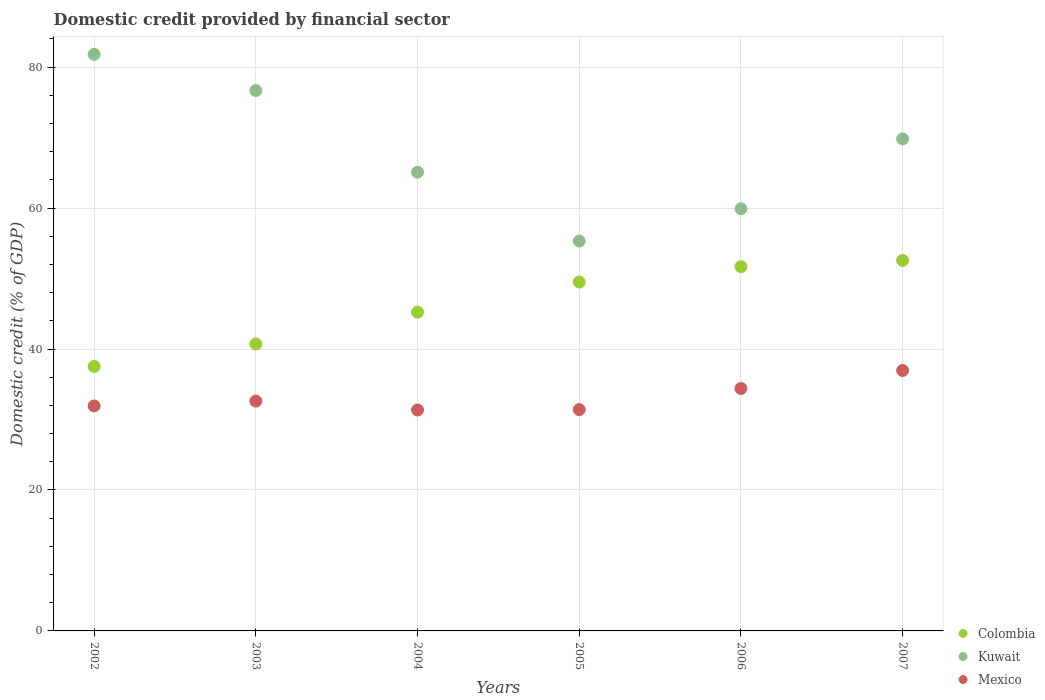Is the number of dotlines equal to the number of legend labels?
Keep it short and to the point. Yes. What is the domestic credit in Colombia in 2002?
Your response must be concise. 37.53. Across all years, what is the maximum domestic credit in Kuwait?
Ensure brevity in your answer.  81.81. Across all years, what is the minimum domestic credit in Colombia?
Provide a succinct answer. 37.53. In which year was the domestic credit in Colombia maximum?
Your answer should be compact. 2007. In which year was the domestic credit in Kuwait minimum?
Your answer should be compact. 2005. What is the total domestic credit in Mexico in the graph?
Provide a succinct answer. 198.64. What is the difference between the domestic credit in Mexico in 2003 and that in 2005?
Offer a terse response. 1.2. What is the difference between the domestic credit in Colombia in 2006 and the domestic credit in Mexico in 2002?
Your answer should be very brief. 19.76. What is the average domestic credit in Mexico per year?
Keep it short and to the point. 33.11. In the year 2004, what is the difference between the domestic credit in Mexico and domestic credit in Colombia?
Provide a short and direct response. -13.89. What is the ratio of the domestic credit in Mexico in 2002 to that in 2007?
Keep it short and to the point. 0.86. Is the domestic credit in Kuwait in 2003 less than that in 2004?
Your response must be concise. No. What is the difference between the highest and the second highest domestic credit in Mexico?
Provide a succinct answer. 2.55. What is the difference between the highest and the lowest domestic credit in Colombia?
Offer a terse response. 15.04. In how many years, is the domestic credit in Colombia greater than the average domestic credit in Colombia taken over all years?
Your answer should be compact. 3. Is the sum of the domestic credit in Kuwait in 2004 and 2005 greater than the maximum domestic credit in Mexico across all years?
Your response must be concise. Yes. Is the domestic credit in Mexico strictly greater than the domestic credit in Colombia over the years?
Give a very brief answer. No. How many dotlines are there?
Your answer should be compact. 3. What is the difference between two consecutive major ticks on the Y-axis?
Make the answer very short. 20. Where does the legend appear in the graph?
Your answer should be very brief. Bottom right. How are the legend labels stacked?
Provide a succinct answer. Vertical. What is the title of the graph?
Give a very brief answer. Domestic credit provided by financial sector. Does "Finland" appear as one of the legend labels in the graph?
Make the answer very short. No. What is the label or title of the X-axis?
Your response must be concise. Years. What is the label or title of the Y-axis?
Provide a succinct answer. Domestic credit (% of GDP). What is the Domestic credit (% of GDP) in Colombia in 2002?
Your answer should be compact. 37.53. What is the Domestic credit (% of GDP) in Kuwait in 2002?
Your response must be concise. 81.81. What is the Domestic credit (% of GDP) in Mexico in 2002?
Your response must be concise. 31.92. What is the Domestic credit (% of GDP) of Colombia in 2003?
Provide a succinct answer. 40.72. What is the Domestic credit (% of GDP) of Kuwait in 2003?
Your answer should be compact. 76.68. What is the Domestic credit (% of GDP) of Mexico in 2003?
Provide a short and direct response. 32.61. What is the Domestic credit (% of GDP) of Colombia in 2004?
Your response must be concise. 45.23. What is the Domestic credit (% of GDP) of Kuwait in 2004?
Your answer should be compact. 65.09. What is the Domestic credit (% of GDP) of Mexico in 2004?
Give a very brief answer. 31.35. What is the Domestic credit (% of GDP) in Colombia in 2005?
Your response must be concise. 49.5. What is the Domestic credit (% of GDP) in Kuwait in 2005?
Offer a very short reply. 55.32. What is the Domestic credit (% of GDP) of Mexico in 2005?
Offer a very short reply. 31.41. What is the Domestic credit (% of GDP) of Colombia in 2006?
Your answer should be very brief. 51.68. What is the Domestic credit (% of GDP) of Kuwait in 2006?
Ensure brevity in your answer.  59.91. What is the Domestic credit (% of GDP) in Mexico in 2006?
Offer a very short reply. 34.4. What is the Domestic credit (% of GDP) of Colombia in 2007?
Your response must be concise. 52.57. What is the Domestic credit (% of GDP) of Kuwait in 2007?
Provide a short and direct response. 69.82. What is the Domestic credit (% of GDP) of Mexico in 2007?
Offer a very short reply. 36.95. Across all years, what is the maximum Domestic credit (% of GDP) of Colombia?
Your answer should be compact. 52.57. Across all years, what is the maximum Domestic credit (% of GDP) in Kuwait?
Provide a succinct answer. 81.81. Across all years, what is the maximum Domestic credit (% of GDP) in Mexico?
Keep it short and to the point. 36.95. Across all years, what is the minimum Domestic credit (% of GDP) of Colombia?
Offer a terse response. 37.53. Across all years, what is the minimum Domestic credit (% of GDP) in Kuwait?
Keep it short and to the point. 55.32. Across all years, what is the minimum Domestic credit (% of GDP) in Mexico?
Ensure brevity in your answer.  31.35. What is the total Domestic credit (% of GDP) of Colombia in the graph?
Give a very brief answer. 277.24. What is the total Domestic credit (% of GDP) in Kuwait in the graph?
Ensure brevity in your answer.  408.62. What is the total Domestic credit (% of GDP) of Mexico in the graph?
Provide a short and direct response. 198.64. What is the difference between the Domestic credit (% of GDP) in Colombia in 2002 and that in 2003?
Your response must be concise. -3.19. What is the difference between the Domestic credit (% of GDP) of Kuwait in 2002 and that in 2003?
Offer a very short reply. 5.13. What is the difference between the Domestic credit (% of GDP) in Mexico in 2002 and that in 2003?
Your response must be concise. -0.69. What is the difference between the Domestic credit (% of GDP) of Colombia in 2002 and that in 2004?
Ensure brevity in your answer.  -7.71. What is the difference between the Domestic credit (% of GDP) of Kuwait in 2002 and that in 2004?
Provide a succinct answer. 16.72. What is the difference between the Domestic credit (% of GDP) in Mexico in 2002 and that in 2004?
Offer a terse response. 0.58. What is the difference between the Domestic credit (% of GDP) in Colombia in 2002 and that in 2005?
Offer a very short reply. -11.97. What is the difference between the Domestic credit (% of GDP) in Kuwait in 2002 and that in 2005?
Provide a short and direct response. 26.49. What is the difference between the Domestic credit (% of GDP) of Mexico in 2002 and that in 2005?
Offer a very short reply. 0.52. What is the difference between the Domestic credit (% of GDP) in Colombia in 2002 and that in 2006?
Ensure brevity in your answer.  -14.15. What is the difference between the Domestic credit (% of GDP) of Kuwait in 2002 and that in 2006?
Provide a succinct answer. 21.9. What is the difference between the Domestic credit (% of GDP) in Mexico in 2002 and that in 2006?
Your response must be concise. -2.48. What is the difference between the Domestic credit (% of GDP) of Colombia in 2002 and that in 2007?
Offer a very short reply. -15.04. What is the difference between the Domestic credit (% of GDP) of Kuwait in 2002 and that in 2007?
Keep it short and to the point. 11.99. What is the difference between the Domestic credit (% of GDP) in Mexico in 2002 and that in 2007?
Give a very brief answer. -5.03. What is the difference between the Domestic credit (% of GDP) in Colombia in 2003 and that in 2004?
Ensure brevity in your answer.  -4.52. What is the difference between the Domestic credit (% of GDP) in Kuwait in 2003 and that in 2004?
Provide a succinct answer. 11.59. What is the difference between the Domestic credit (% of GDP) in Mexico in 2003 and that in 2004?
Provide a succinct answer. 1.26. What is the difference between the Domestic credit (% of GDP) in Colombia in 2003 and that in 2005?
Your response must be concise. -8.79. What is the difference between the Domestic credit (% of GDP) of Kuwait in 2003 and that in 2005?
Offer a very short reply. 21.36. What is the difference between the Domestic credit (% of GDP) in Mexico in 2003 and that in 2005?
Make the answer very short. 1.2. What is the difference between the Domestic credit (% of GDP) in Colombia in 2003 and that in 2006?
Offer a very short reply. -10.97. What is the difference between the Domestic credit (% of GDP) of Kuwait in 2003 and that in 2006?
Provide a short and direct response. 16.77. What is the difference between the Domestic credit (% of GDP) in Mexico in 2003 and that in 2006?
Offer a terse response. -1.79. What is the difference between the Domestic credit (% of GDP) of Colombia in 2003 and that in 2007?
Your answer should be compact. -11.85. What is the difference between the Domestic credit (% of GDP) of Kuwait in 2003 and that in 2007?
Give a very brief answer. 6.86. What is the difference between the Domestic credit (% of GDP) of Mexico in 2003 and that in 2007?
Provide a succinct answer. -4.34. What is the difference between the Domestic credit (% of GDP) in Colombia in 2004 and that in 2005?
Your answer should be compact. -4.27. What is the difference between the Domestic credit (% of GDP) of Kuwait in 2004 and that in 2005?
Offer a very short reply. 9.77. What is the difference between the Domestic credit (% of GDP) of Mexico in 2004 and that in 2005?
Keep it short and to the point. -0.06. What is the difference between the Domestic credit (% of GDP) in Colombia in 2004 and that in 2006?
Ensure brevity in your answer.  -6.45. What is the difference between the Domestic credit (% of GDP) of Kuwait in 2004 and that in 2006?
Keep it short and to the point. 5.18. What is the difference between the Domestic credit (% of GDP) of Mexico in 2004 and that in 2006?
Offer a very short reply. -3.05. What is the difference between the Domestic credit (% of GDP) of Colombia in 2004 and that in 2007?
Give a very brief answer. -7.34. What is the difference between the Domestic credit (% of GDP) of Kuwait in 2004 and that in 2007?
Offer a very short reply. -4.72. What is the difference between the Domestic credit (% of GDP) in Mexico in 2004 and that in 2007?
Your response must be concise. -5.61. What is the difference between the Domestic credit (% of GDP) in Colombia in 2005 and that in 2006?
Your answer should be compact. -2.18. What is the difference between the Domestic credit (% of GDP) in Kuwait in 2005 and that in 2006?
Your response must be concise. -4.59. What is the difference between the Domestic credit (% of GDP) of Mexico in 2005 and that in 2006?
Your answer should be very brief. -2.99. What is the difference between the Domestic credit (% of GDP) of Colombia in 2005 and that in 2007?
Provide a short and direct response. -3.07. What is the difference between the Domestic credit (% of GDP) in Kuwait in 2005 and that in 2007?
Provide a short and direct response. -14.49. What is the difference between the Domestic credit (% of GDP) of Mexico in 2005 and that in 2007?
Your answer should be compact. -5.55. What is the difference between the Domestic credit (% of GDP) in Colombia in 2006 and that in 2007?
Provide a short and direct response. -0.89. What is the difference between the Domestic credit (% of GDP) in Kuwait in 2006 and that in 2007?
Make the answer very short. -9.91. What is the difference between the Domestic credit (% of GDP) of Mexico in 2006 and that in 2007?
Keep it short and to the point. -2.55. What is the difference between the Domestic credit (% of GDP) in Colombia in 2002 and the Domestic credit (% of GDP) in Kuwait in 2003?
Your response must be concise. -39.15. What is the difference between the Domestic credit (% of GDP) in Colombia in 2002 and the Domestic credit (% of GDP) in Mexico in 2003?
Give a very brief answer. 4.92. What is the difference between the Domestic credit (% of GDP) of Kuwait in 2002 and the Domestic credit (% of GDP) of Mexico in 2003?
Your answer should be compact. 49.2. What is the difference between the Domestic credit (% of GDP) of Colombia in 2002 and the Domestic credit (% of GDP) of Kuwait in 2004?
Offer a terse response. -27.56. What is the difference between the Domestic credit (% of GDP) of Colombia in 2002 and the Domestic credit (% of GDP) of Mexico in 2004?
Your answer should be compact. 6.18. What is the difference between the Domestic credit (% of GDP) of Kuwait in 2002 and the Domestic credit (% of GDP) of Mexico in 2004?
Your answer should be very brief. 50.46. What is the difference between the Domestic credit (% of GDP) of Colombia in 2002 and the Domestic credit (% of GDP) of Kuwait in 2005?
Make the answer very short. -17.79. What is the difference between the Domestic credit (% of GDP) of Colombia in 2002 and the Domestic credit (% of GDP) of Mexico in 2005?
Give a very brief answer. 6.12. What is the difference between the Domestic credit (% of GDP) of Kuwait in 2002 and the Domestic credit (% of GDP) of Mexico in 2005?
Provide a succinct answer. 50.4. What is the difference between the Domestic credit (% of GDP) in Colombia in 2002 and the Domestic credit (% of GDP) in Kuwait in 2006?
Your response must be concise. -22.38. What is the difference between the Domestic credit (% of GDP) of Colombia in 2002 and the Domestic credit (% of GDP) of Mexico in 2006?
Provide a succinct answer. 3.13. What is the difference between the Domestic credit (% of GDP) in Kuwait in 2002 and the Domestic credit (% of GDP) in Mexico in 2006?
Give a very brief answer. 47.41. What is the difference between the Domestic credit (% of GDP) of Colombia in 2002 and the Domestic credit (% of GDP) of Kuwait in 2007?
Keep it short and to the point. -32.29. What is the difference between the Domestic credit (% of GDP) in Colombia in 2002 and the Domestic credit (% of GDP) in Mexico in 2007?
Offer a very short reply. 0.57. What is the difference between the Domestic credit (% of GDP) of Kuwait in 2002 and the Domestic credit (% of GDP) of Mexico in 2007?
Provide a succinct answer. 44.86. What is the difference between the Domestic credit (% of GDP) of Colombia in 2003 and the Domestic credit (% of GDP) of Kuwait in 2004?
Your answer should be very brief. -24.37. What is the difference between the Domestic credit (% of GDP) in Colombia in 2003 and the Domestic credit (% of GDP) in Mexico in 2004?
Provide a short and direct response. 9.37. What is the difference between the Domestic credit (% of GDP) of Kuwait in 2003 and the Domestic credit (% of GDP) of Mexico in 2004?
Provide a short and direct response. 45.33. What is the difference between the Domestic credit (% of GDP) of Colombia in 2003 and the Domestic credit (% of GDP) of Kuwait in 2005?
Offer a terse response. -14.6. What is the difference between the Domestic credit (% of GDP) of Colombia in 2003 and the Domestic credit (% of GDP) of Mexico in 2005?
Keep it short and to the point. 9.31. What is the difference between the Domestic credit (% of GDP) in Kuwait in 2003 and the Domestic credit (% of GDP) in Mexico in 2005?
Ensure brevity in your answer.  45.27. What is the difference between the Domestic credit (% of GDP) in Colombia in 2003 and the Domestic credit (% of GDP) in Kuwait in 2006?
Your answer should be compact. -19.19. What is the difference between the Domestic credit (% of GDP) of Colombia in 2003 and the Domestic credit (% of GDP) of Mexico in 2006?
Your response must be concise. 6.32. What is the difference between the Domestic credit (% of GDP) in Kuwait in 2003 and the Domestic credit (% of GDP) in Mexico in 2006?
Your answer should be compact. 42.28. What is the difference between the Domestic credit (% of GDP) of Colombia in 2003 and the Domestic credit (% of GDP) of Kuwait in 2007?
Your answer should be compact. -29.1. What is the difference between the Domestic credit (% of GDP) of Colombia in 2003 and the Domestic credit (% of GDP) of Mexico in 2007?
Offer a very short reply. 3.76. What is the difference between the Domestic credit (% of GDP) of Kuwait in 2003 and the Domestic credit (% of GDP) of Mexico in 2007?
Offer a very short reply. 39.72. What is the difference between the Domestic credit (% of GDP) of Colombia in 2004 and the Domestic credit (% of GDP) of Kuwait in 2005?
Keep it short and to the point. -10.09. What is the difference between the Domestic credit (% of GDP) of Colombia in 2004 and the Domestic credit (% of GDP) of Mexico in 2005?
Your answer should be compact. 13.83. What is the difference between the Domestic credit (% of GDP) of Kuwait in 2004 and the Domestic credit (% of GDP) of Mexico in 2005?
Make the answer very short. 33.68. What is the difference between the Domestic credit (% of GDP) in Colombia in 2004 and the Domestic credit (% of GDP) in Kuwait in 2006?
Offer a terse response. -14.67. What is the difference between the Domestic credit (% of GDP) in Colombia in 2004 and the Domestic credit (% of GDP) in Mexico in 2006?
Offer a terse response. 10.83. What is the difference between the Domestic credit (% of GDP) of Kuwait in 2004 and the Domestic credit (% of GDP) of Mexico in 2006?
Give a very brief answer. 30.69. What is the difference between the Domestic credit (% of GDP) in Colombia in 2004 and the Domestic credit (% of GDP) in Kuwait in 2007?
Keep it short and to the point. -24.58. What is the difference between the Domestic credit (% of GDP) of Colombia in 2004 and the Domestic credit (% of GDP) of Mexico in 2007?
Your answer should be compact. 8.28. What is the difference between the Domestic credit (% of GDP) in Kuwait in 2004 and the Domestic credit (% of GDP) in Mexico in 2007?
Ensure brevity in your answer.  28.14. What is the difference between the Domestic credit (% of GDP) in Colombia in 2005 and the Domestic credit (% of GDP) in Kuwait in 2006?
Offer a very short reply. -10.4. What is the difference between the Domestic credit (% of GDP) in Colombia in 2005 and the Domestic credit (% of GDP) in Mexico in 2006?
Your answer should be very brief. 15.1. What is the difference between the Domestic credit (% of GDP) in Kuwait in 2005 and the Domestic credit (% of GDP) in Mexico in 2006?
Keep it short and to the point. 20.92. What is the difference between the Domestic credit (% of GDP) of Colombia in 2005 and the Domestic credit (% of GDP) of Kuwait in 2007?
Offer a very short reply. -20.31. What is the difference between the Domestic credit (% of GDP) of Colombia in 2005 and the Domestic credit (% of GDP) of Mexico in 2007?
Provide a succinct answer. 12.55. What is the difference between the Domestic credit (% of GDP) of Kuwait in 2005 and the Domestic credit (% of GDP) of Mexico in 2007?
Ensure brevity in your answer.  18.37. What is the difference between the Domestic credit (% of GDP) in Colombia in 2006 and the Domestic credit (% of GDP) in Kuwait in 2007?
Provide a succinct answer. -18.13. What is the difference between the Domestic credit (% of GDP) of Colombia in 2006 and the Domestic credit (% of GDP) of Mexico in 2007?
Ensure brevity in your answer.  14.73. What is the difference between the Domestic credit (% of GDP) in Kuwait in 2006 and the Domestic credit (% of GDP) in Mexico in 2007?
Your answer should be compact. 22.95. What is the average Domestic credit (% of GDP) in Colombia per year?
Keep it short and to the point. 46.21. What is the average Domestic credit (% of GDP) of Kuwait per year?
Your answer should be very brief. 68.1. What is the average Domestic credit (% of GDP) of Mexico per year?
Your response must be concise. 33.11. In the year 2002, what is the difference between the Domestic credit (% of GDP) in Colombia and Domestic credit (% of GDP) in Kuwait?
Keep it short and to the point. -44.28. In the year 2002, what is the difference between the Domestic credit (% of GDP) of Colombia and Domestic credit (% of GDP) of Mexico?
Keep it short and to the point. 5.61. In the year 2002, what is the difference between the Domestic credit (% of GDP) in Kuwait and Domestic credit (% of GDP) in Mexico?
Make the answer very short. 49.89. In the year 2003, what is the difference between the Domestic credit (% of GDP) of Colombia and Domestic credit (% of GDP) of Kuwait?
Provide a short and direct response. -35.96. In the year 2003, what is the difference between the Domestic credit (% of GDP) in Colombia and Domestic credit (% of GDP) in Mexico?
Ensure brevity in your answer.  8.11. In the year 2003, what is the difference between the Domestic credit (% of GDP) of Kuwait and Domestic credit (% of GDP) of Mexico?
Give a very brief answer. 44.07. In the year 2004, what is the difference between the Domestic credit (% of GDP) in Colombia and Domestic credit (% of GDP) in Kuwait?
Your response must be concise. -19.86. In the year 2004, what is the difference between the Domestic credit (% of GDP) in Colombia and Domestic credit (% of GDP) in Mexico?
Offer a very short reply. 13.89. In the year 2004, what is the difference between the Domestic credit (% of GDP) of Kuwait and Domestic credit (% of GDP) of Mexico?
Your answer should be very brief. 33.74. In the year 2005, what is the difference between the Domestic credit (% of GDP) of Colombia and Domestic credit (% of GDP) of Kuwait?
Your response must be concise. -5.82. In the year 2005, what is the difference between the Domestic credit (% of GDP) of Colombia and Domestic credit (% of GDP) of Mexico?
Provide a succinct answer. 18.1. In the year 2005, what is the difference between the Domestic credit (% of GDP) in Kuwait and Domestic credit (% of GDP) in Mexico?
Your answer should be compact. 23.91. In the year 2006, what is the difference between the Domestic credit (% of GDP) in Colombia and Domestic credit (% of GDP) in Kuwait?
Provide a short and direct response. -8.22. In the year 2006, what is the difference between the Domestic credit (% of GDP) in Colombia and Domestic credit (% of GDP) in Mexico?
Offer a very short reply. 17.28. In the year 2006, what is the difference between the Domestic credit (% of GDP) in Kuwait and Domestic credit (% of GDP) in Mexico?
Your answer should be compact. 25.51. In the year 2007, what is the difference between the Domestic credit (% of GDP) in Colombia and Domestic credit (% of GDP) in Kuwait?
Provide a succinct answer. -17.25. In the year 2007, what is the difference between the Domestic credit (% of GDP) of Colombia and Domestic credit (% of GDP) of Mexico?
Your answer should be compact. 15.62. In the year 2007, what is the difference between the Domestic credit (% of GDP) in Kuwait and Domestic credit (% of GDP) in Mexico?
Your answer should be very brief. 32.86. What is the ratio of the Domestic credit (% of GDP) of Colombia in 2002 to that in 2003?
Your answer should be compact. 0.92. What is the ratio of the Domestic credit (% of GDP) in Kuwait in 2002 to that in 2003?
Offer a terse response. 1.07. What is the ratio of the Domestic credit (% of GDP) in Mexico in 2002 to that in 2003?
Ensure brevity in your answer.  0.98. What is the ratio of the Domestic credit (% of GDP) of Colombia in 2002 to that in 2004?
Keep it short and to the point. 0.83. What is the ratio of the Domestic credit (% of GDP) in Kuwait in 2002 to that in 2004?
Make the answer very short. 1.26. What is the ratio of the Domestic credit (% of GDP) in Mexico in 2002 to that in 2004?
Make the answer very short. 1.02. What is the ratio of the Domestic credit (% of GDP) in Colombia in 2002 to that in 2005?
Make the answer very short. 0.76. What is the ratio of the Domestic credit (% of GDP) of Kuwait in 2002 to that in 2005?
Your answer should be very brief. 1.48. What is the ratio of the Domestic credit (% of GDP) of Mexico in 2002 to that in 2005?
Provide a succinct answer. 1.02. What is the ratio of the Domestic credit (% of GDP) of Colombia in 2002 to that in 2006?
Make the answer very short. 0.73. What is the ratio of the Domestic credit (% of GDP) of Kuwait in 2002 to that in 2006?
Your answer should be compact. 1.37. What is the ratio of the Domestic credit (% of GDP) in Mexico in 2002 to that in 2006?
Keep it short and to the point. 0.93. What is the ratio of the Domestic credit (% of GDP) in Colombia in 2002 to that in 2007?
Keep it short and to the point. 0.71. What is the ratio of the Domestic credit (% of GDP) of Kuwait in 2002 to that in 2007?
Your answer should be very brief. 1.17. What is the ratio of the Domestic credit (% of GDP) in Mexico in 2002 to that in 2007?
Provide a succinct answer. 0.86. What is the ratio of the Domestic credit (% of GDP) of Colombia in 2003 to that in 2004?
Give a very brief answer. 0.9. What is the ratio of the Domestic credit (% of GDP) of Kuwait in 2003 to that in 2004?
Offer a very short reply. 1.18. What is the ratio of the Domestic credit (% of GDP) of Mexico in 2003 to that in 2004?
Ensure brevity in your answer.  1.04. What is the ratio of the Domestic credit (% of GDP) in Colombia in 2003 to that in 2005?
Provide a short and direct response. 0.82. What is the ratio of the Domestic credit (% of GDP) in Kuwait in 2003 to that in 2005?
Provide a short and direct response. 1.39. What is the ratio of the Domestic credit (% of GDP) in Mexico in 2003 to that in 2005?
Your answer should be compact. 1.04. What is the ratio of the Domestic credit (% of GDP) of Colombia in 2003 to that in 2006?
Your answer should be compact. 0.79. What is the ratio of the Domestic credit (% of GDP) in Kuwait in 2003 to that in 2006?
Provide a succinct answer. 1.28. What is the ratio of the Domestic credit (% of GDP) of Mexico in 2003 to that in 2006?
Offer a terse response. 0.95. What is the ratio of the Domestic credit (% of GDP) in Colombia in 2003 to that in 2007?
Your response must be concise. 0.77. What is the ratio of the Domestic credit (% of GDP) in Kuwait in 2003 to that in 2007?
Ensure brevity in your answer.  1.1. What is the ratio of the Domestic credit (% of GDP) in Mexico in 2003 to that in 2007?
Offer a terse response. 0.88. What is the ratio of the Domestic credit (% of GDP) of Colombia in 2004 to that in 2005?
Your answer should be compact. 0.91. What is the ratio of the Domestic credit (% of GDP) of Kuwait in 2004 to that in 2005?
Keep it short and to the point. 1.18. What is the ratio of the Domestic credit (% of GDP) in Mexico in 2004 to that in 2005?
Make the answer very short. 1. What is the ratio of the Domestic credit (% of GDP) of Colombia in 2004 to that in 2006?
Give a very brief answer. 0.88. What is the ratio of the Domestic credit (% of GDP) of Kuwait in 2004 to that in 2006?
Give a very brief answer. 1.09. What is the ratio of the Domestic credit (% of GDP) of Mexico in 2004 to that in 2006?
Give a very brief answer. 0.91. What is the ratio of the Domestic credit (% of GDP) in Colombia in 2004 to that in 2007?
Ensure brevity in your answer.  0.86. What is the ratio of the Domestic credit (% of GDP) of Kuwait in 2004 to that in 2007?
Your answer should be compact. 0.93. What is the ratio of the Domestic credit (% of GDP) of Mexico in 2004 to that in 2007?
Ensure brevity in your answer.  0.85. What is the ratio of the Domestic credit (% of GDP) in Colombia in 2005 to that in 2006?
Your answer should be very brief. 0.96. What is the ratio of the Domestic credit (% of GDP) of Kuwait in 2005 to that in 2006?
Your answer should be very brief. 0.92. What is the ratio of the Domestic credit (% of GDP) of Colombia in 2005 to that in 2007?
Keep it short and to the point. 0.94. What is the ratio of the Domestic credit (% of GDP) of Kuwait in 2005 to that in 2007?
Your response must be concise. 0.79. What is the ratio of the Domestic credit (% of GDP) of Mexico in 2005 to that in 2007?
Ensure brevity in your answer.  0.85. What is the ratio of the Domestic credit (% of GDP) in Colombia in 2006 to that in 2007?
Provide a short and direct response. 0.98. What is the ratio of the Domestic credit (% of GDP) in Kuwait in 2006 to that in 2007?
Your response must be concise. 0.86. What is the ratio of the Domestic credit (% of GDP) of Mexico in 2006 to that in 2007?
Make the answer very short. 0.93. What is the difference between the highest and the second highest Domestic credit (% of GDP) of Colombia?
Offer a very short reply. 0.89. What is the difference between the highest and the second highest Domestic credit (% of GDP) of Kuwait?
Provide a short and direct response. 5.13. What is the difference between the highest and the second highest Domestic credit (% of GDP) of Mexico?
Offer a very short reply. 2.55. What is the difference between the highest and the lowest Domestic credit (% of GDP) in Colombia?
Make the answer very short. 15.04. What is the difference between the highest and the lowest Domestic credit (% of GDP) in Kuwait?
Keep it short and to the point. 26.49. What is the difference between the highest and the lowest Domestic credit (% of GDP) of Mexico?
Provide a short and direct response. 5.61. 